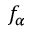<formula> <loc_0><loc_0><loc_500><loc_500>f _ { \alpha }</formula> 